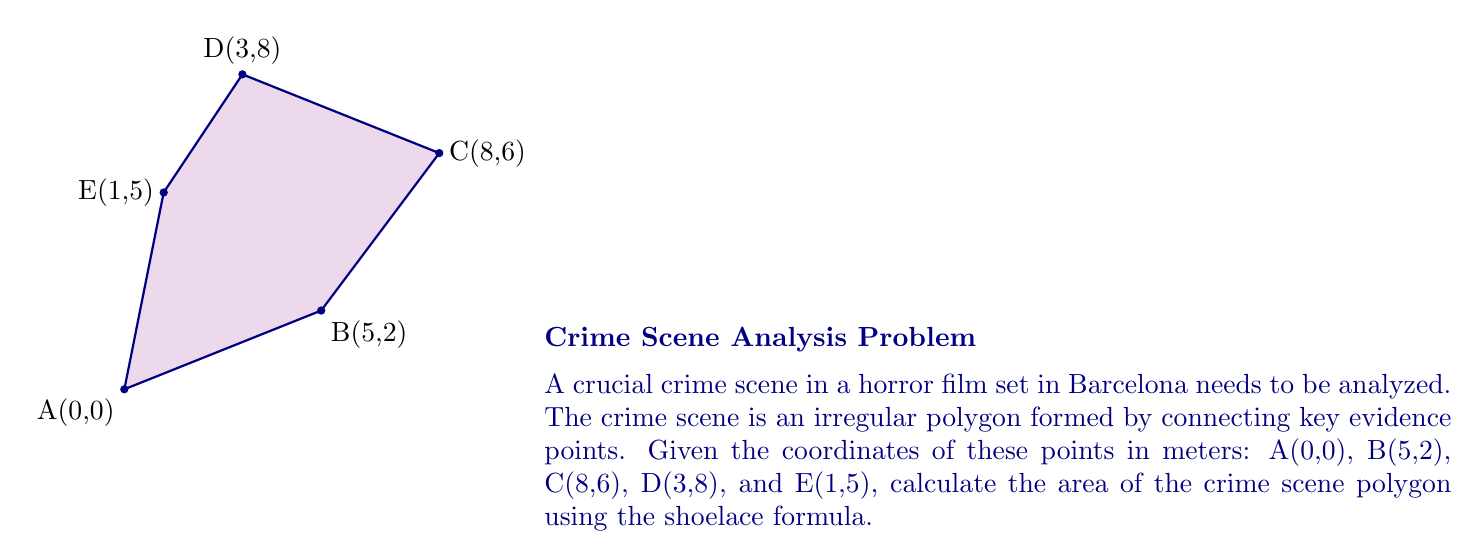Give your solution to this math problem. To calculate the area of this irregular polygon, we'll use the shoelace formula:

$$Area = \frac{1}{2}|\sum_{i=1}^{n-1} (x_iy_{i+1} + x_ny_1) - \sum_{i=1}^{n-1} (x_{i+1}y_i + x_1y_n)|$$

Where $(x_i, y_i)$ are the coordinates of the $i$-th vertex.

Step 1: List the coordinates in order:
(0,0), (5,2), (8,6), (3,8), (1,5)

Step 2: Calculate the first sum:
$$(0 \cdot 2 + 5 \cdot 6 + 8 \cdot 8 + 3 \cdot 5 + 1 \cdot 0) = 0 + 30 + 64 + 15 + 0 = 109$$

Step 3: Calculate the second sum:
$$(5 \cdot 0 + 8 \cdot 2 + 3 \cdot 6 + 1 \cdot 8 + 0 \cdot 5) = 0 + 16 + 18 + 8 + 0 = 42$$

Step 4: Subtract the second sum from the first:
$$109 - 42 = 67$$

Step 5: Take the absolute value and divide by 2:
$$Area = \frac{1}{2}|67| = 33.5$$

Therefore, the area of the crime scene polygon is 33.5 square meters.
Answer: 33.5 m² 